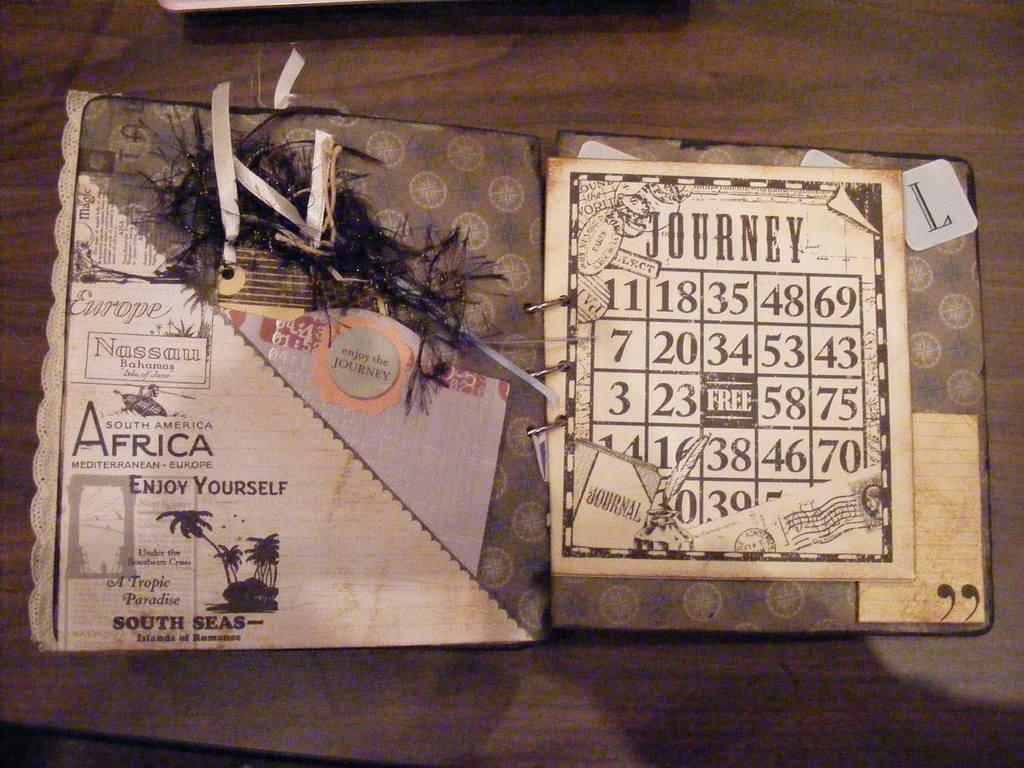<image>
Provide a brief description of the given image. A game in a ringed binder called Journey. 